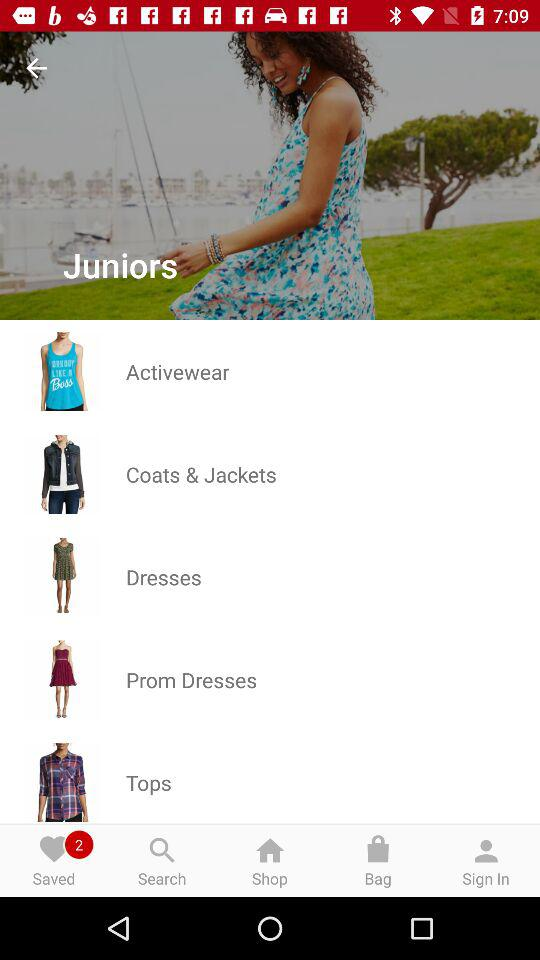How many prom dresses are available?
When the provided information is insufficient, respond with <no answer>. <no answer> 